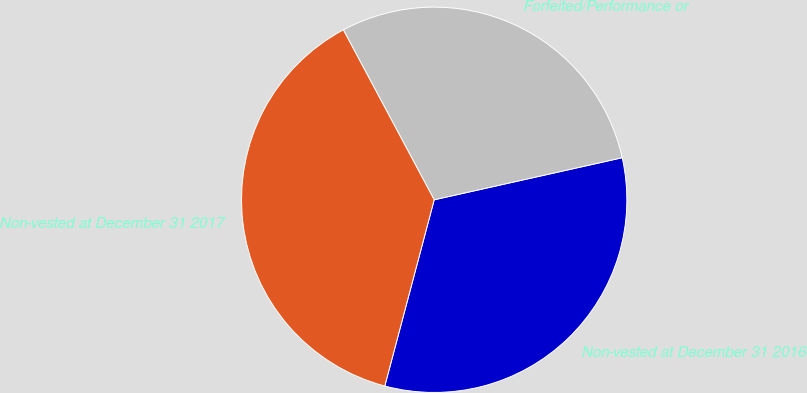Convert chart. <chart><loc_0><loc_0><loc_500><loc_500><pie_chart><fcel>Non-vested at December 31 2016<fcel>Forfeited/Performance or<fcel>Non-vested at December 31 2017<nl><fcel>32.63%<fcel>29.31%<fcel>38.06%<nl></chart> 